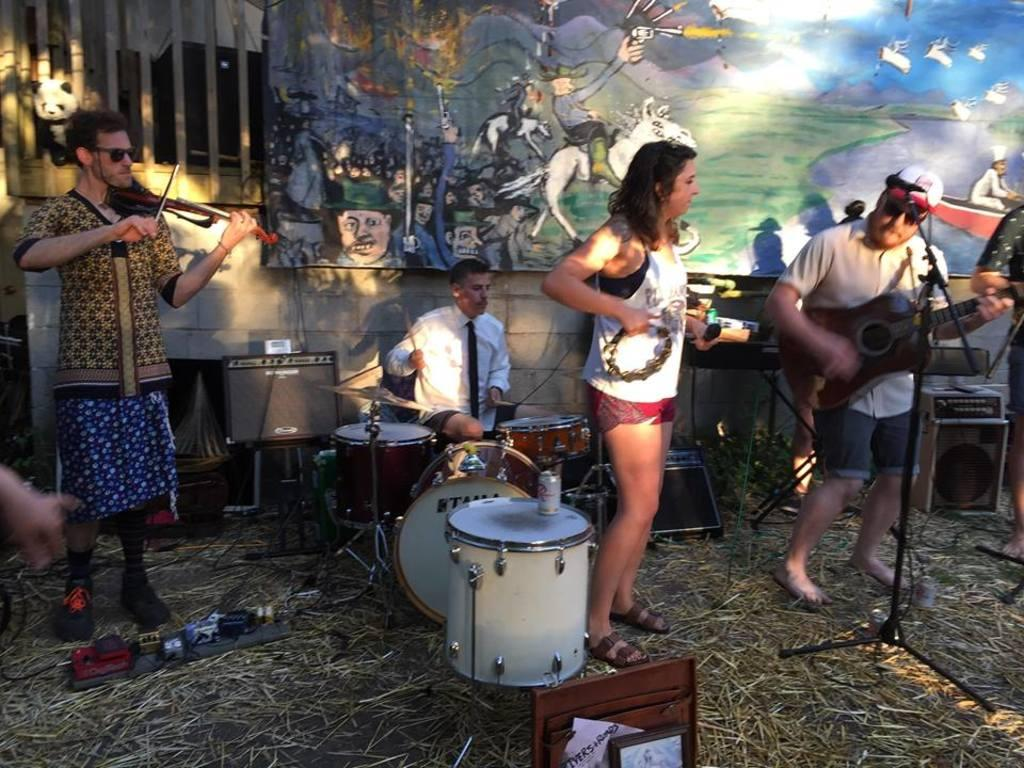How many people are in the image? There are four people in the image. What are the people doing in the image? Each person is playing a different musical instrument. Where are the people playing their instruments? The people are playing the instruments on the grass. What type of planes can be seen flying in the image? There are no planes visible in the image; it features four people playing musical instruments on the grass. What kind of system is being used by the people to play their instruments? The provided facts do not mention any specific system being used by the people to play their instruments. 